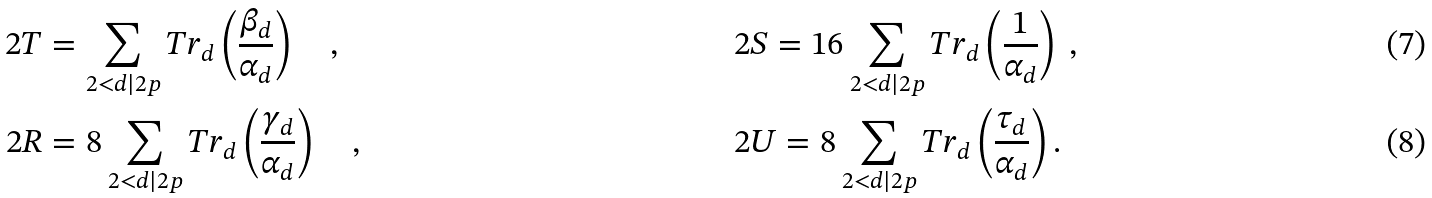<formula> <loc_0><loc_0><loc_500><loc_500>2 T & = \sum _ { 2 < d | 2 p } T r _ { d } \left ( \frac { \beta _ { d } } { \alpha _ { d } } \right ) \quad , \quad & & 2 S = 1 6 \sum _ { 2 < d | 2 p } T r _ { d } \left ( \frac { 1 } { \alpha _ { d } } \right ) \ , \ \\ 2 R & = 8 \sum _ { 2 < d | 2 p } T r _ { d } \left ( \frac { \gamma _ { d } } { \alpha _ { d } } \right ) \quad , \quad & & 2 U = 8 \sum _ { 2 < d | 2 p } T r _ { d } \left ( \frac { \tau _ { d } } { \alpha _ { d } } \right ) .</formula> 